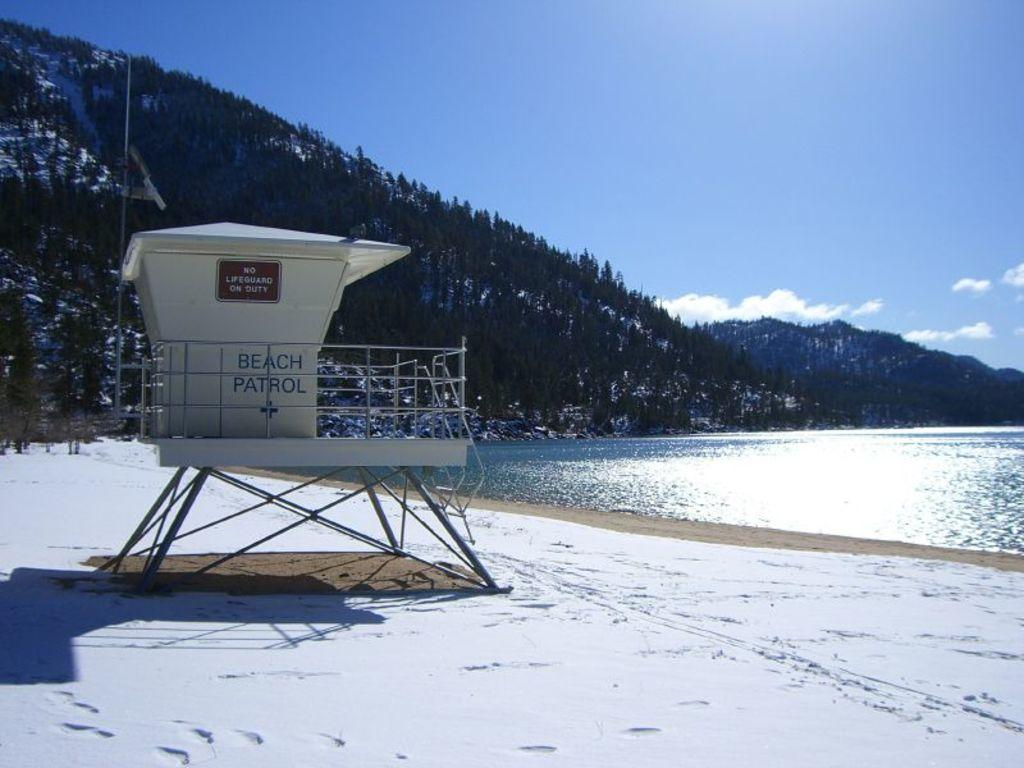What type of natural environment is depicted in the image? The image features trees and water, suggesting a natural environment such as a beach or lake. What can be seen on the shore in the image? There is a beach patrol on the shore in the image. How would you describe the sky in the image? The sky is blue and cloudy in the image. What is the ground covered with in the image? The ground is covered with snow in the image. Where are the frogs hopping on the street in the image? There are no frogs present in the image, and therefore no such activity can be observed. 